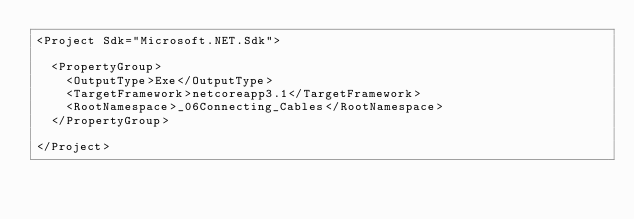Convert code to text. <code><loc_0><loc_0><loc_500><loc_500><_XML_><Project Sdk="Microsoft.NET.Sdk">

  <PropertyGroup>
    <OutputType>Exe</OutputType>
    <TargetFramework>netcoreapp3.1</TargetFramework>
    <RootNamespace>_06Connecting_Cables</RootNamespace>
  </PropertyGroup>

</Project>
</code> 